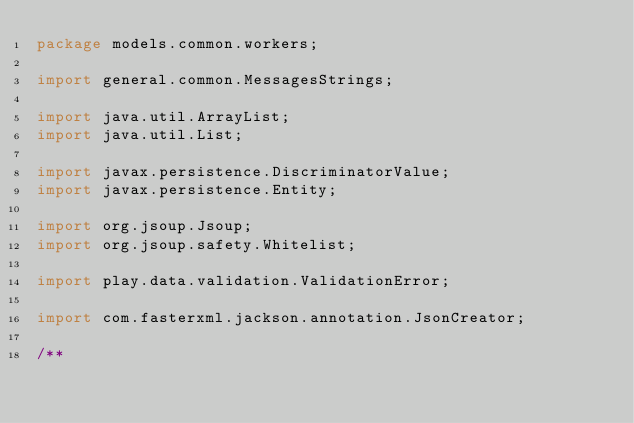Convert code to text. <code><loc_0><loc_0><loc_500><loc_500><_Java_>package models.common.workers;

import general.common.MessagesStrings;

import java.util.ArrayList;
import java.util.List;

import javax.persistence.DiscriminatorValue;
import javax.persistence.Entity;

import org.jsoup.Jsoup;
import org.jsoup.safety.Whitelist;

import play.data.validation.ValidationError;

import com.fasterxml.jackson.annotation.JsonCreator;

/**</code> 